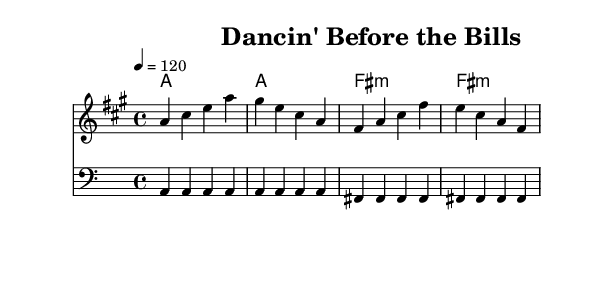What is the key signature of this music? The key signature is A major, which has three sharps: F#, C#, and G#. This is found at the beginning of the sheet music where the key signature is indicated.
Answer: A major What is the time signature of this piece? The time signature is 4/4, seen directly in the signature at the beginning of the music. This indicates that there are four beats per measure and a quarter note gets one beat.
Answer: 4/4 What is the tempo marking for the music? The tempo marking is 120 beats per minute, indicated by the tempo instruction "4 = 120" at the start. This indicates the speed at which the music should be played.
Answer: 120 How many measures are there in the melody? The melody consists of 8 measures, identified by counting the groups of notes within the staff. Each line and space arrangement of notes represents a measure, totaling 8 in this case.
Answer: 8 What is the chord being played in the first measure? The chord in the first measure is A major, as indicated by the chord symbol 'a' placed above the staff. This tells us the harmonic context for the notes being played.
Answer: A major What is the primary bass note in the first half of the piece? The primary bass note is A, as seen in the bassline, where the note A is played repeatedly in the first four measures. This establishes a strong foundation for the melody.
Answer: A 